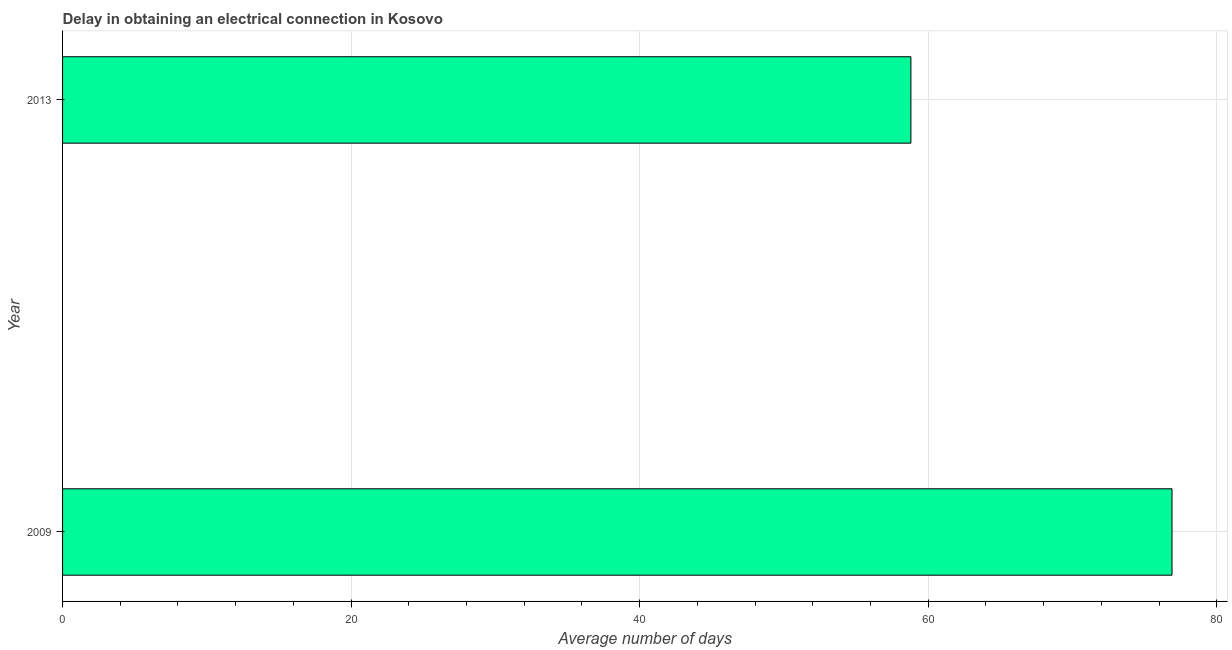Does the graph contain any zero values?
Provide a short and direct response. No. What is the title of the graph?
Make the answer very short. Delay in obtaining an electrical connection in Kosovo. What is the label or title of the X-axis?
Your answer should be very brief. Average number of days. What is the dalay in electrical connection in 2013?
Offer a very short reply. 58.8. Across all years, what is the maximum dalay in electrical connection?
Your answer should be very brief. 76.9. Across all years, what is the minimum dalay in electrical connection?
Your answer should be very brief. 58.8. In which year was the dalay in electrical connection maximum?
Offer a terse response. 2009. In which year was the dalay in electrical connection minimum?
Offer a very short reply. 2013. What is the sum of the dalay in electrical connection?
Offer a very short reply. 135.7. What is the difference between the dalay in electrical connection in 2009 and 2013?
Keep it short and to the point. 18.1. What is the average dalay in electrical connection per year?
Give a very brief answer. 67.85. What is the median dalay in electrical connection?
Offer a terse response. 67.85. Do a majority of the years between 2009 and 2013 (inclusive) have dalay in electrical connection greater than 68 days?
Give a very brief answer. No. What is the ratio of the dalay in electrical connection in 2009 to that in 2013?
Ensure brevity in your answer.  1.31. What is the difference between two consecutive major ticks on the X-axis?
Provide a succinct answer. 20. Are the values on the major ticks of X-axis written in scientific E-notation?
Provide a succinct answer. No. What is the Average number of days in 2009?
Ensure brevity in your answer.  76.9. What is the Average number of days in 2013?
Your response must be concise. 58.8. What is the difference between the Average number of days in 2009 and 2013?
Your response must be concise. 18.1. What is the ratio of the Average number of days in 2009 to that in 2013?
Ensure brevity in your answer.  1.31. 